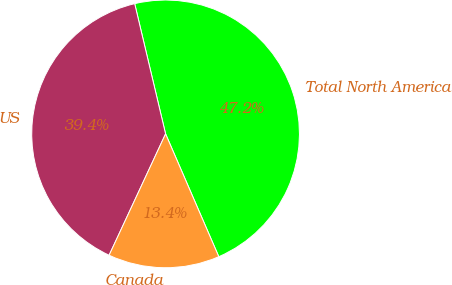<chart> <loc_0><loc_0><loc_500><loc_500><pie_chart><fcel>Total North America<fcel>US<fcel>Canada<nl><fcel>47.2%<fcel>39.36%<fcel>13.44%<nl></chart> 